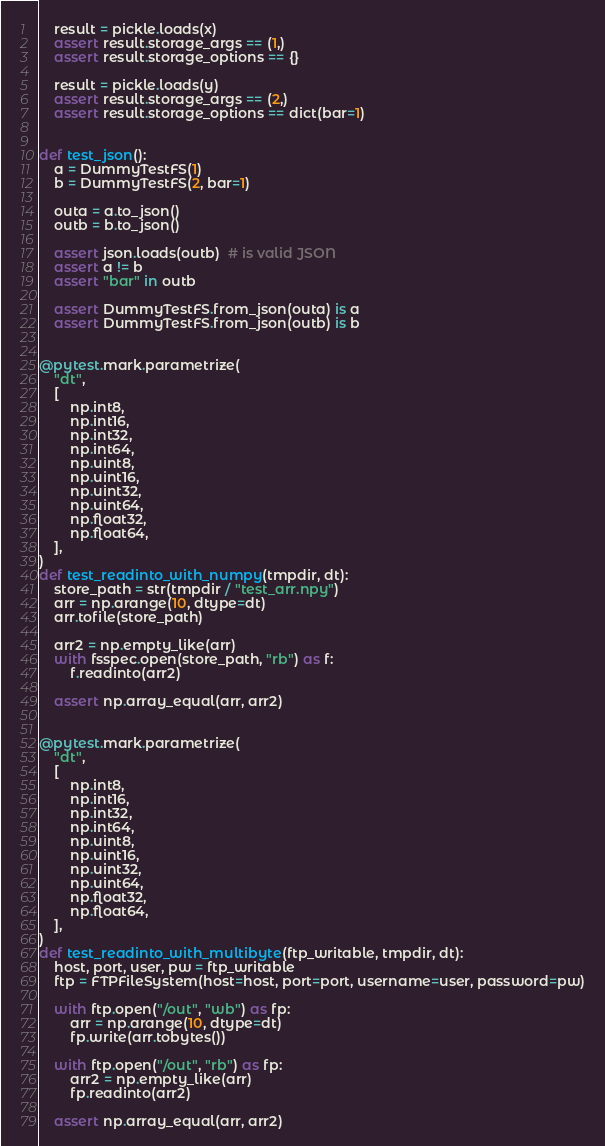<code> <loc_0><loc_0><loc_500><loc_500><_Python_>    result = pickle.loads(x)
    assert result.storage_args == (1,)
    assert result.storage_options == {}

    result = pickle.loads(y)
    assert result.storage_args == (2,)
    assert result.storage_options == dict(bar=1)


def test_json():
    a = DummyTestFS(1)
    b = DummyTestFS(2, bar=1)

    outa = a.to_json()
    outb = b.to_json()

    assert json.loads(outb)  # is valid JSON
    assert a != b
    assert "bar" in outb

    assert DummyTestFS.from_json(outa) is a
    assert DummyTestFS.from_json(outb) is b


@pytest.mark.parametrize(
    "dt",
    [
        np.int8,
        np.int16,
        np.int32,
        np.int64,
        np.uint8,
        np.uint16,
        np.uint32,
        np.uint64,
        np.float32,
        np.float64,
    ],
)
def test_readinto_with_numpy(tmpdir, dt):
    store_path = str(tmpdir / "test_arr.npy")
    arr = np.arange(10, dtype=dt)
    arr.tofile(store_path)

    arr2 = np.empty_like(arr)
    with fsspec.open(store_path, "rb") as f:
        f.readinto(arr2)

    assert np.array_equal(arr, arr2)


@pytest.mark.parametrize(
    "dt",
    [
        np.int8,
        np.int16,
        np.int32,
        np.int64,
        np.uint8,
        np.uint16,
        np.uint32,
        np.uint64,
        np.float32,
        np.float64,
    ],
)
def test_readinto_with_multibyte(ftp_writable, tmpdir, dt):
    host, port, user, pw = ftp_writable
    ftp = FTPFileSystem(host=host, port=port, username=user, password=pw)

    with ftp.open("/out", "wb") as fp:
        arr = np.arange(10, dtype=dt)
        fp.write(arr.tobytes())

    with ftp.open("/out", "rb") as fp:
        arr2 = np.empty_like(arr)
        fp.readinto(arr2)

    assert np.array_equal(arr, arr2)
</code> 